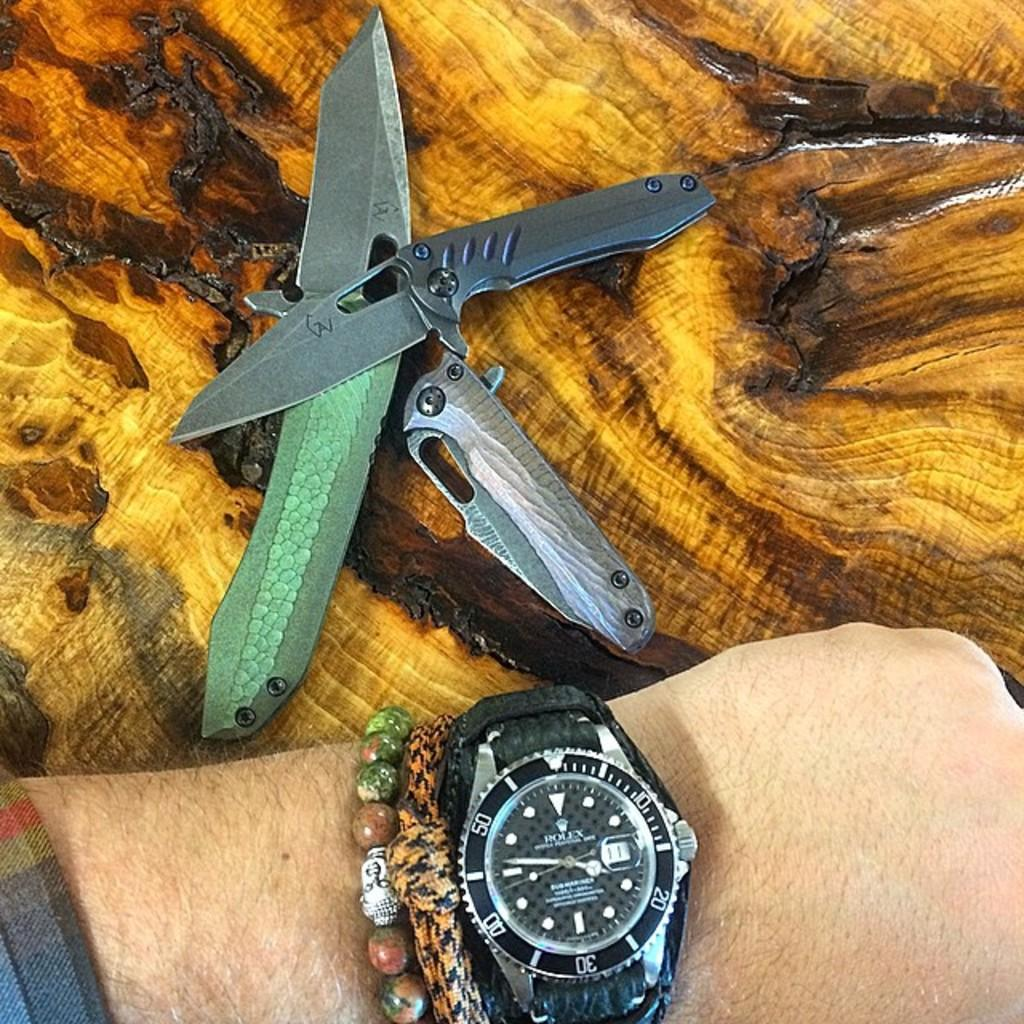<image>
Present a compact description of the photo's key features. Rolex men's watch with gears on side of outer edge, plus two opened switchblades next to hand wearing watch. 